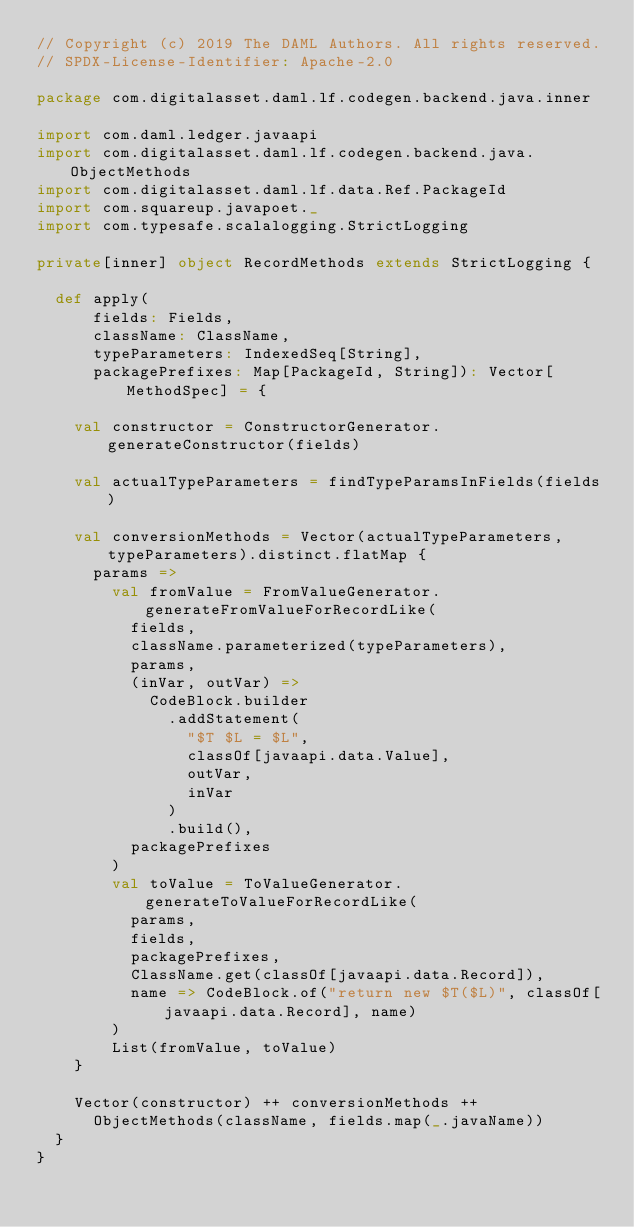<code> <loc_0><loc_0><loc_500><loc_500><_Scala_>// Copyright (c) 2019 The DAML Authors. All rights reserved.
// SPDX-License-Identifier: Apache-2.0

package com.digitalasset.daml.lf.codegen.backend.java.inner

import com.daml.ledger.javaapi
import com.digitalasset.daml.lf.codegen.backend.java.ObjectMethods
import com.digitalasset.daml.lf.data.Ref.PackageId
import com.squareup.javapoet._
import com.typesafe.scalalogging.StrictLogging

private[inner] object RecordMethods extends StrictLogging {

  def apply(
      fields: Fields,
      className: ClassName,
      typeParameters: IndexedSeq[String],
      packagePrefixes: Map[PackageId, String]): Vector[MethodSpec] = {

    val constructor = ConstructorGenerator.generateConstructor(fields)

    val actualTypeParameters = findTypeParamsInFields(fields)

    val conversionMethods = Vector(actualTypeParameters, typeParameters).distinct.flatMap {
      params =>
        val fromValue = FromValueGenerator.generateFromValueForRecordLike(
          fields,
          className.parameterized(typeParameters),
          params,
          (inVar, outVar) =>
            CodeBlock.builder
              .addStatement(
                "$T $L = $L",
                classOf[javaapi.data.Value],
                outVar,
                inVar
              )
              .build(),
          packagePrefixes
        )
        val toValue = ToValueGenerator.generateToValueForRecordLike(
          params,
          fields,
          packagePrefixes,
          ClassName.get(classOf[javaapi.data.Record]),
          name => CodeBlock.of("return new $T($L)", classOf[javaapi.data.Record], name)
        )
        List(fromValue, toValue)
    }

    Vector(constructor) ++ conversionMethods ++
      ObjectMethods(className, fields.map(_.javaName))
  }
}
</code> 